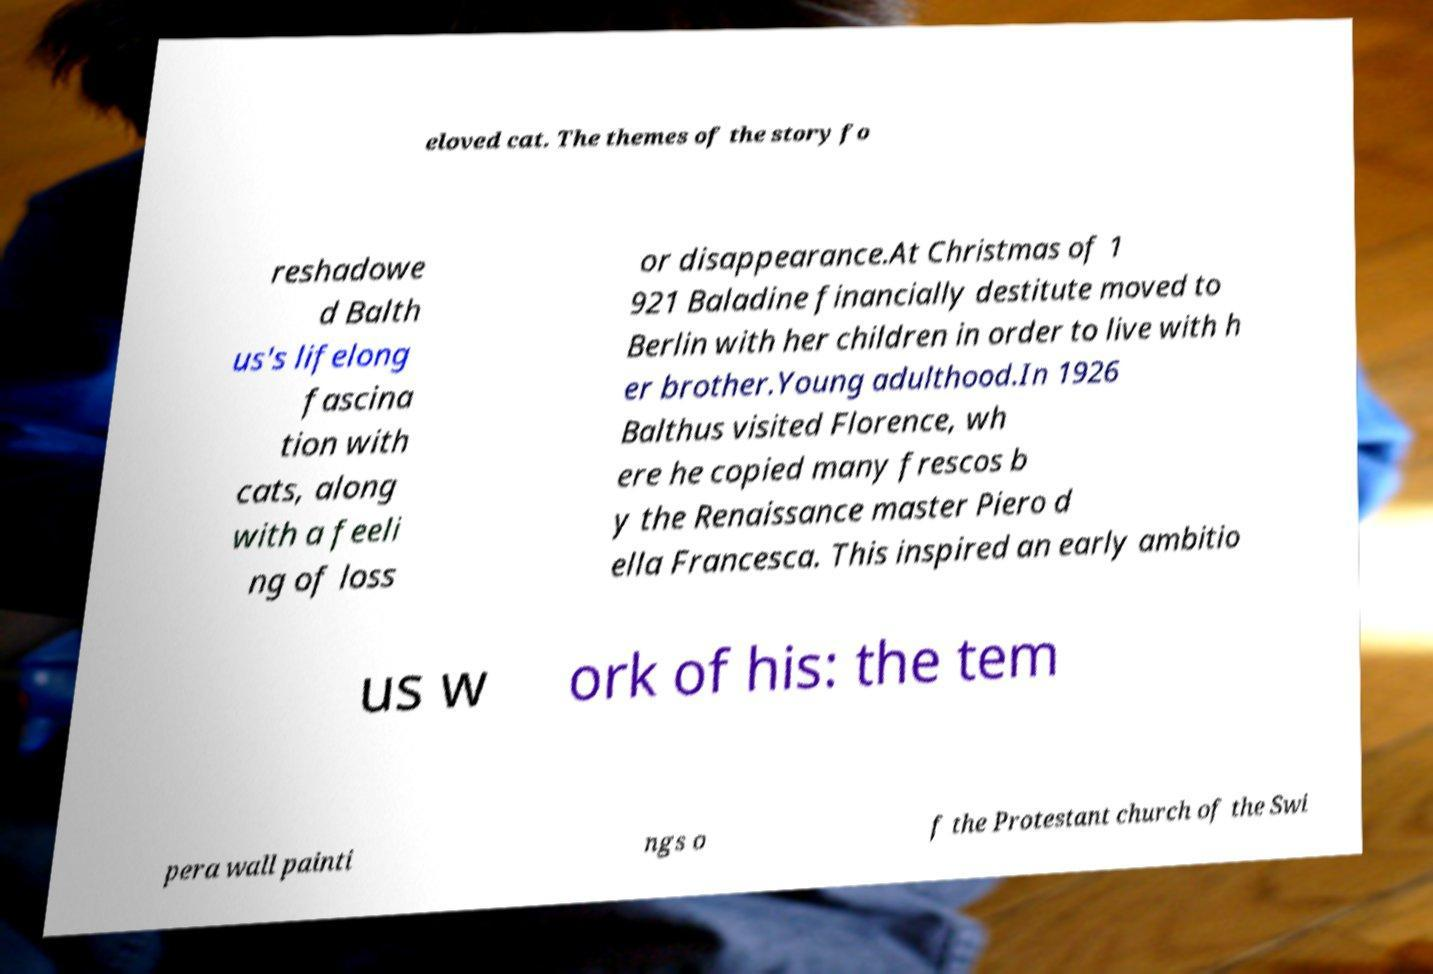I need the written content from this picture converted into text. Can you do that? eloved cat. The themes of the story fo reshadowe d Balth us's lifelong fascina tion with cats, along with a feeli ng of loss or disappearance.At Christmas of 1 921 Baladine financially destitute moved to Berlin with her children in order to live with h er brother.Young adulthood.In 1926 Balthus visited Florence, wh ere he copied many frescos b y the Renaissance master Piero d ella Francesca. This inspired an early ambitio us w ork of his: the tem pera wall painti ngs o f the Protestant church of the Swi 